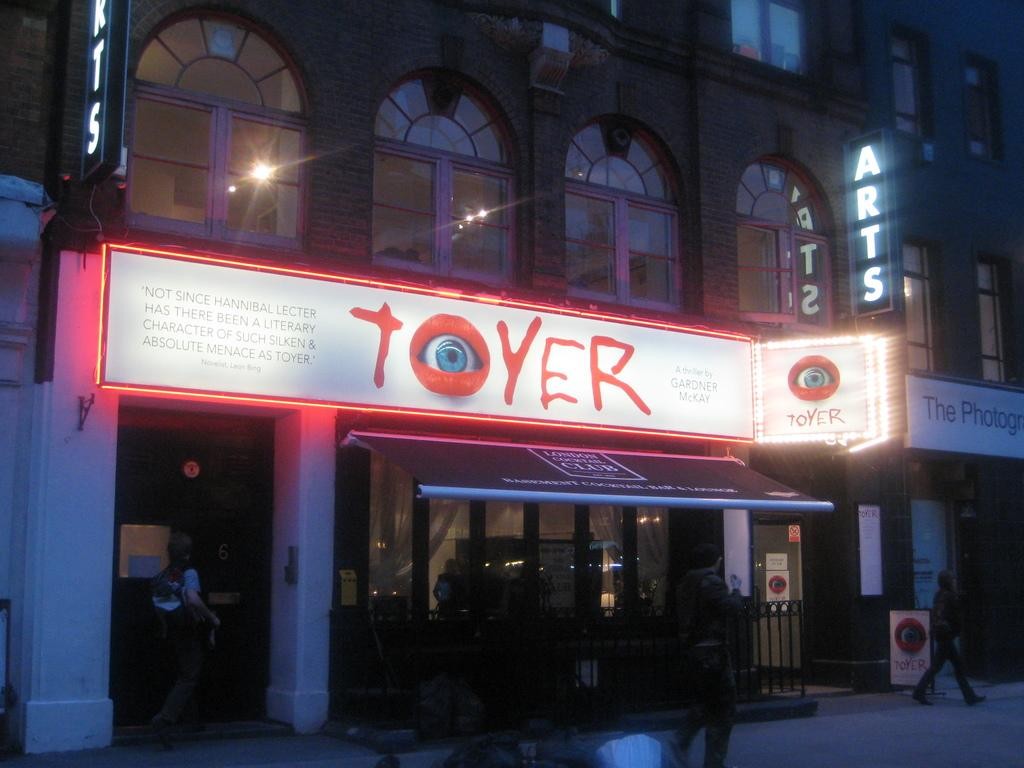What is happening at the bottom of the image? There is a crowd on the road at the bottom of the image. What objects can be seen in the image besides the crowd? There are boards visible in the image. What is located in the background of the image? There is a building in the background of the image. What feature of the building is mentioned in the facts? Windows are present in the building. What time of day is the image taken? The image is taken during night. How much money is being exchanged between the people in the crowd? There is no indication of money exchange in the image; it only shows a crowd on the road and boards. What type of chain is holding the building together in the image? There is no chain mentioned or visible in the image; it only features a building with windows in the background. 